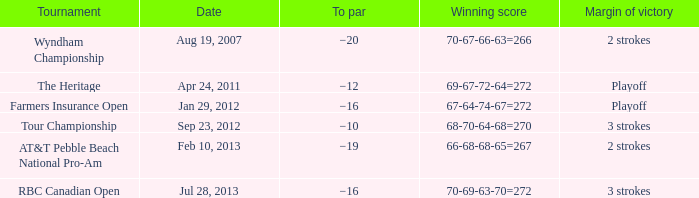What is the to par of the match with a winning score 69-67-72-64=272? −12. 